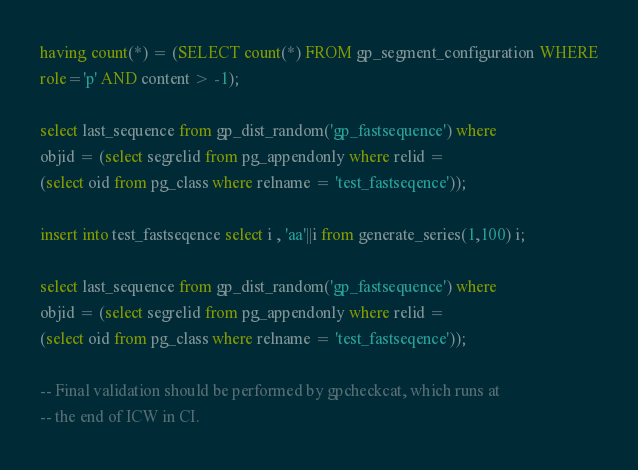Convert code to text. <code><loc_0><loc_0><loc_500><loc_500><_SQL_>having count(*) = (SELECT count(*) FROM gp_segment_configuration WHERE
role='p' AND content > -1);

select last_sequence from gp_dist_random('gp_fastsequence') where
objid = (select segrelid from pg_appendonly where relid =
(select oid from pg_class where relname = 'test_fastseqence'));

insert into test_fastseqence select i , 'aa'||i from generate_series(1,100) i;

select last_sequence from gp_dist_random('gp_fastsequence') where
objid = (select segrelid from pg_appendonly where relid =
(select oid from pg_class where relname = 'test_fastseqence'));

-- Final validation should be performed by gpcheckcat, which runs at
-- the end of ICW in CI.
</code> 